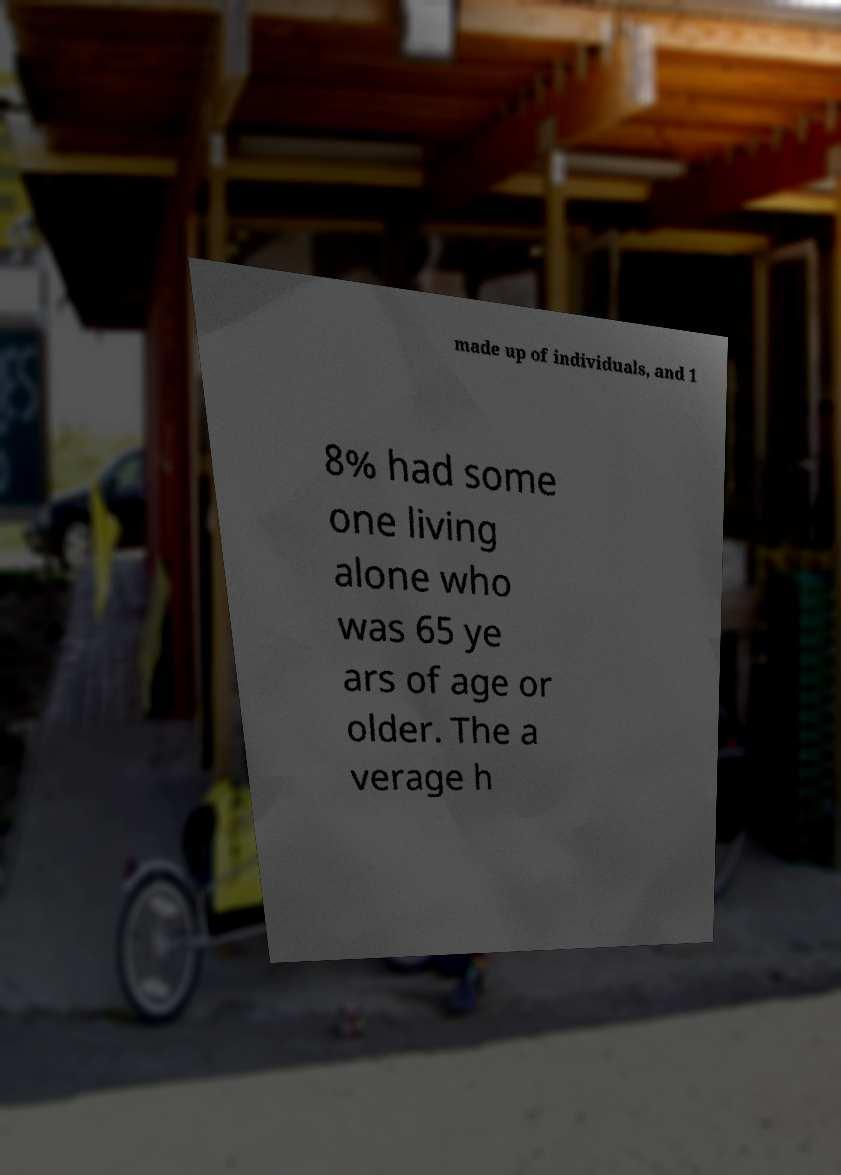Could you assist in decoding the text presented in this image and type it out clearly? made up of individuals, and 1 8% had some one living alone who was 65 ye ars of age or older. The a verage h 